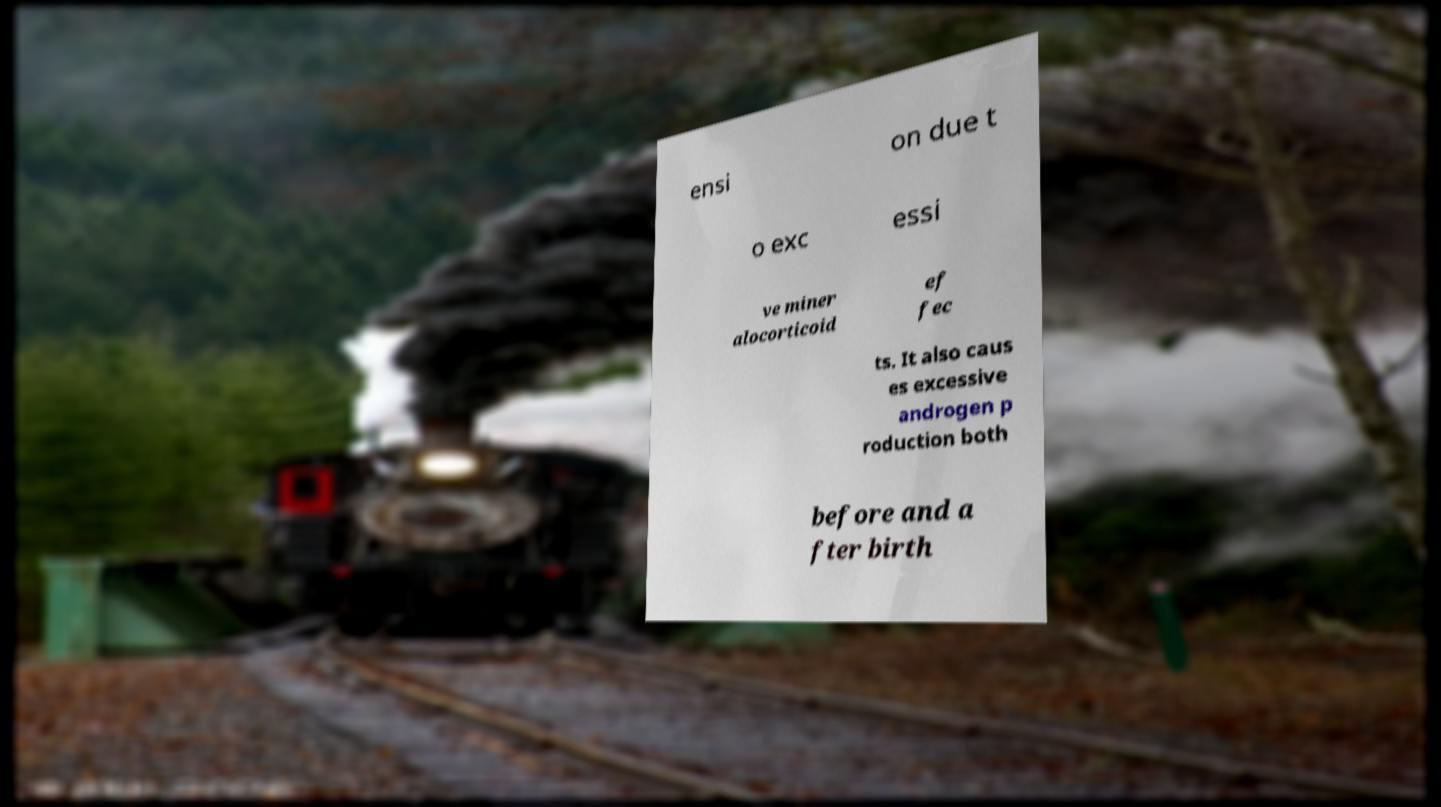What messages or text are displayed in this image? I need them in a readable, typed format. ensi on due t o exc essi ve miner alocorticoid ef fec ts. It also caus es excessive androgen p roduction both before and a fter birth 